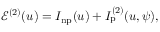Convert formula to latex. <formula><loc_0><loc_0><loc_500><loc_500>\begin{array} { r } { \mathcal { E } ^ { ( 2 ) } ( u ) = I _ { n p } ( u ) + I _ { p } ^ { ( 2 ) } ( u , \psi ) , } \end{array}</formula> 